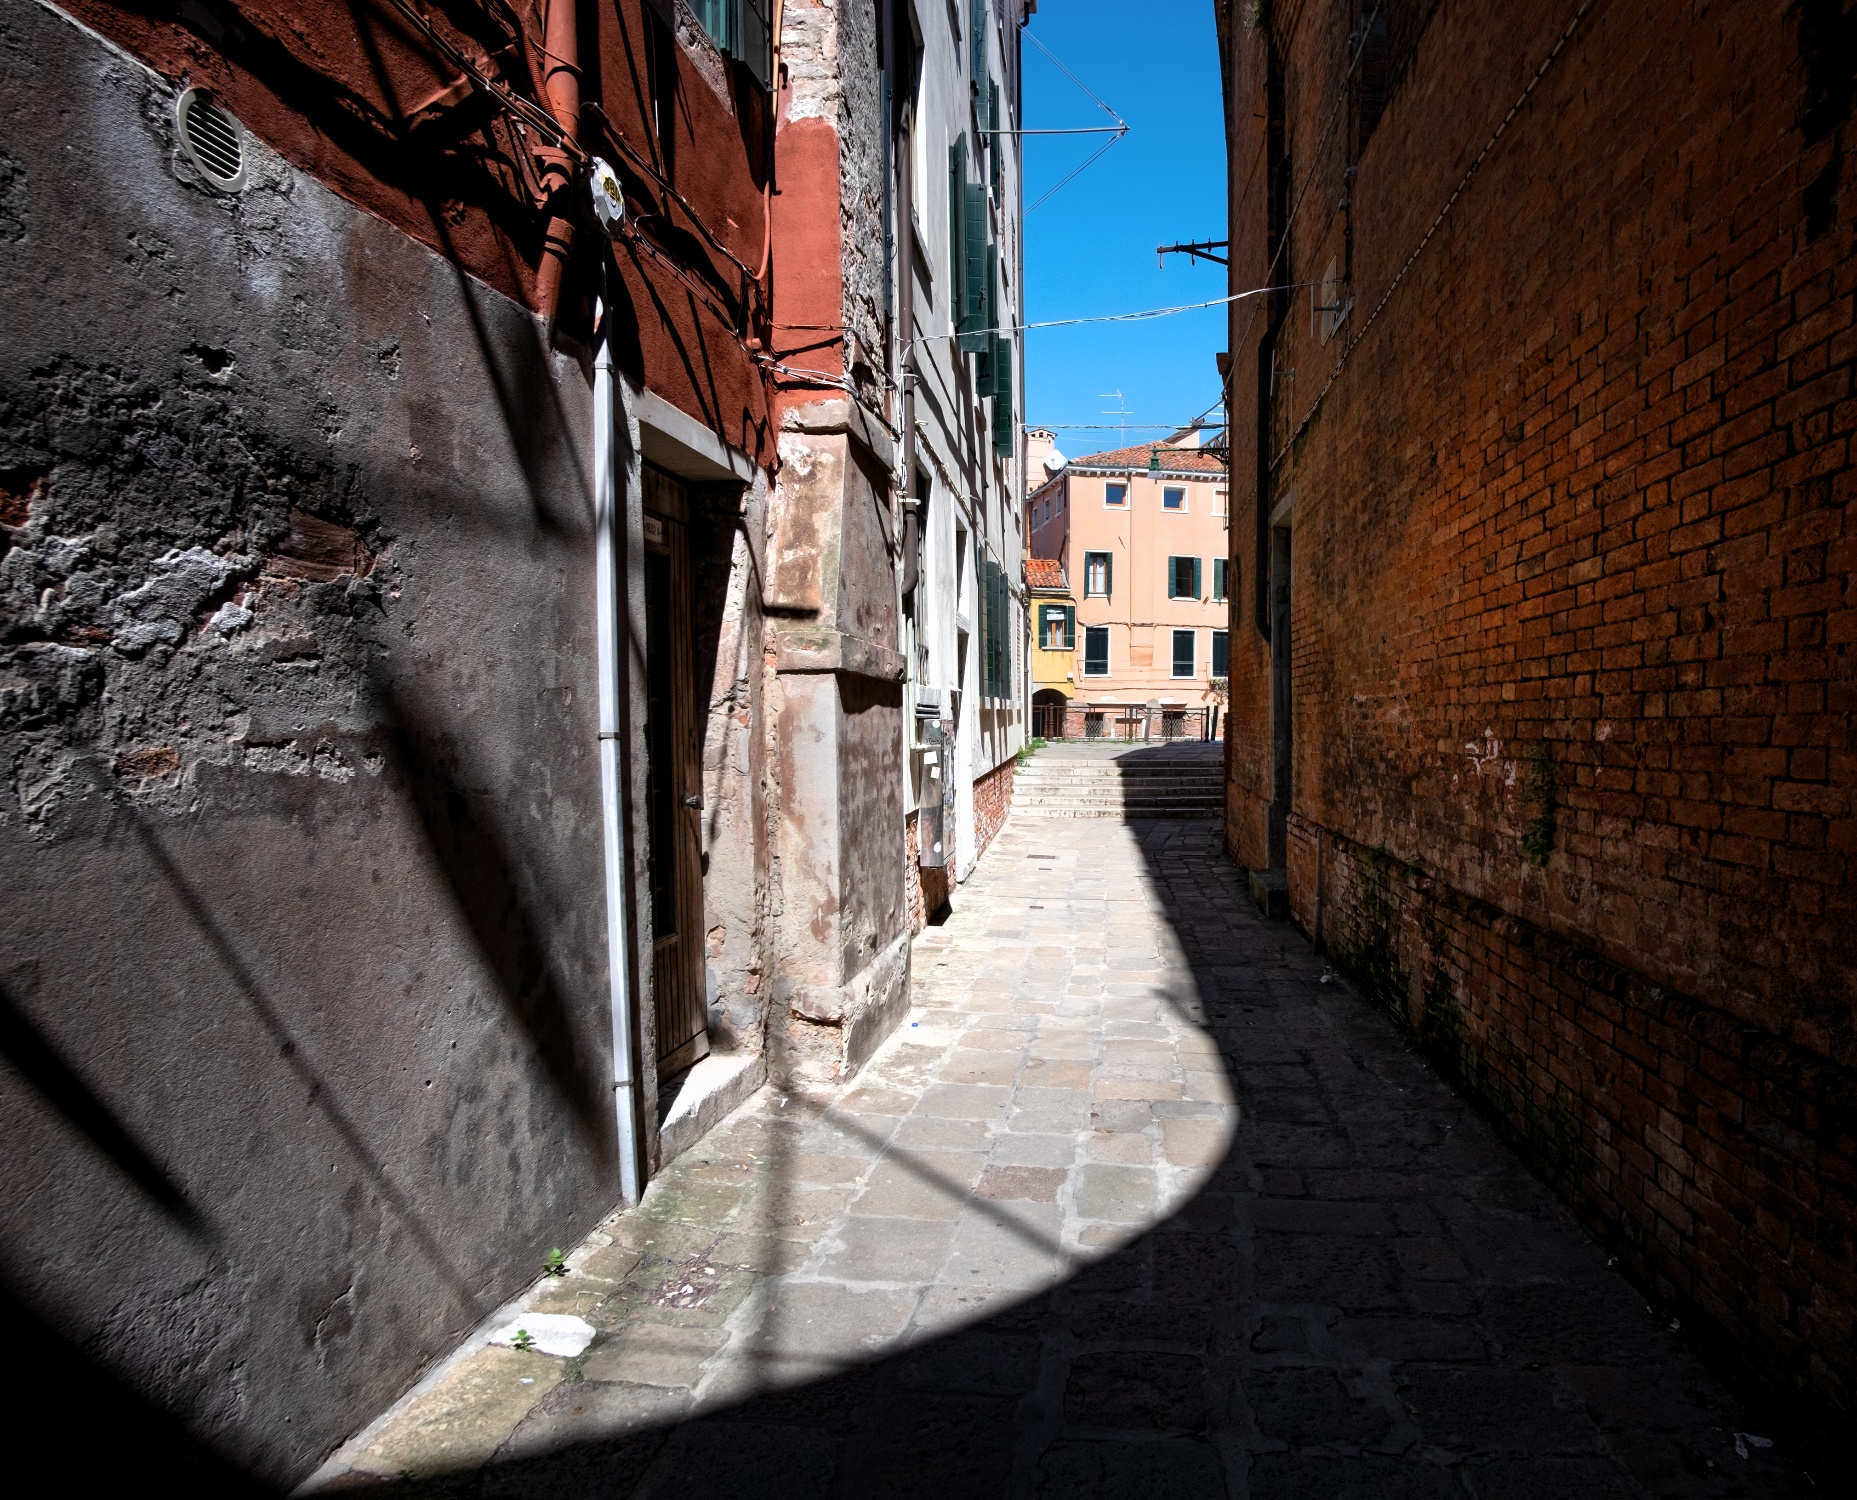What might this alleyway look like during a rainy day? On a rainy day, this alleyway would likely take on a moody and somewhat nostalgic ambiance. The cobblestone street would glisten under the rain, reflecting the muted tones of the old brick buildings. Raindrops would streak down the weathered surfaces, accentuating their textures. The smell of wet stone and earth would be pervasive, and you might hear the rhythmic patter of rain against the buildings and ground. People would hastily traverse the street, umbrellas in hand, adding splashes of color to the otherwise greyish-scene. The entire alleyway would seem to hum with the sound of falling rain and the occasional distant rumble of thunder, making it a serene, almost cinematic experience. 